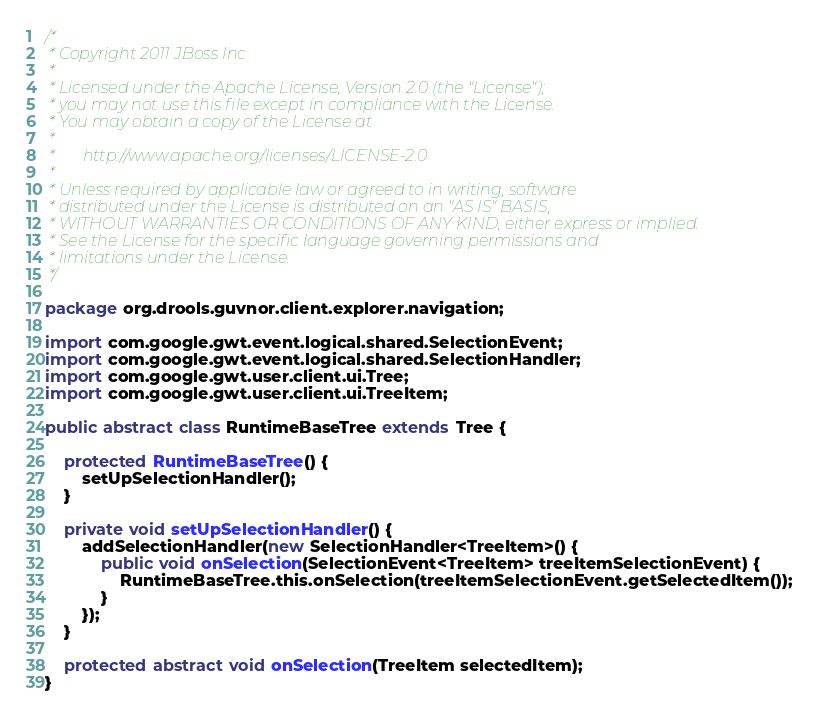Convert code to text. <code><loc_0><loc_0><loc_500><loc_500><_Java_>/*
 * Copyright 2011 JBoss Inc
 *
 * Licensed under the Apache License, Version 2.0 (the "License");
 * you may not use this file except in compliance with the License.
 * You may obtain a copy of the License at
 *
 *       http://www.apache.org/licenses/LICENSE-2.0
 *
 * Unless required by applicable law or agreed to in writing, software
 * distributed under the License is distributed on an "AS IS" BASIS,
 * WITHOUT WARRANTIES OR CONDITIONS OF ANY KIND, either express or implied.
 * See the License for the specific language governing permissions and
 * limitations under the License.
 */

package org.drools.guvnor.client.explorer.navigation;

import com.google.gwt.event.logical.shared.SelectionEvent;
import com.google.gwt.event.logical.shared.SelectionHandler;
import com.google.gwt.user.client.ui.Tree;
import com.google.gwt.user.client.ui.TreeItem;

public abstract class RuntimeBaseTree extends Tree {

    protected RuntimeBaseTree() {
        setUpSelectionHandler();
    }

    private void setUpSelectionHandler() {
        addSelectionHandler(new SelectionHandler<TreeItem>() {
            public void onSelection(SelectionEvent<TreeItem> treeItemSelectionEvent) {
                RuntimeBaseTree.this.onSelection(treeItemSelectionEvent.getSelectedItem());
            }
        });
    }

    protected abstract void onSelection(TreeItem selectedItem);
}
</code> 